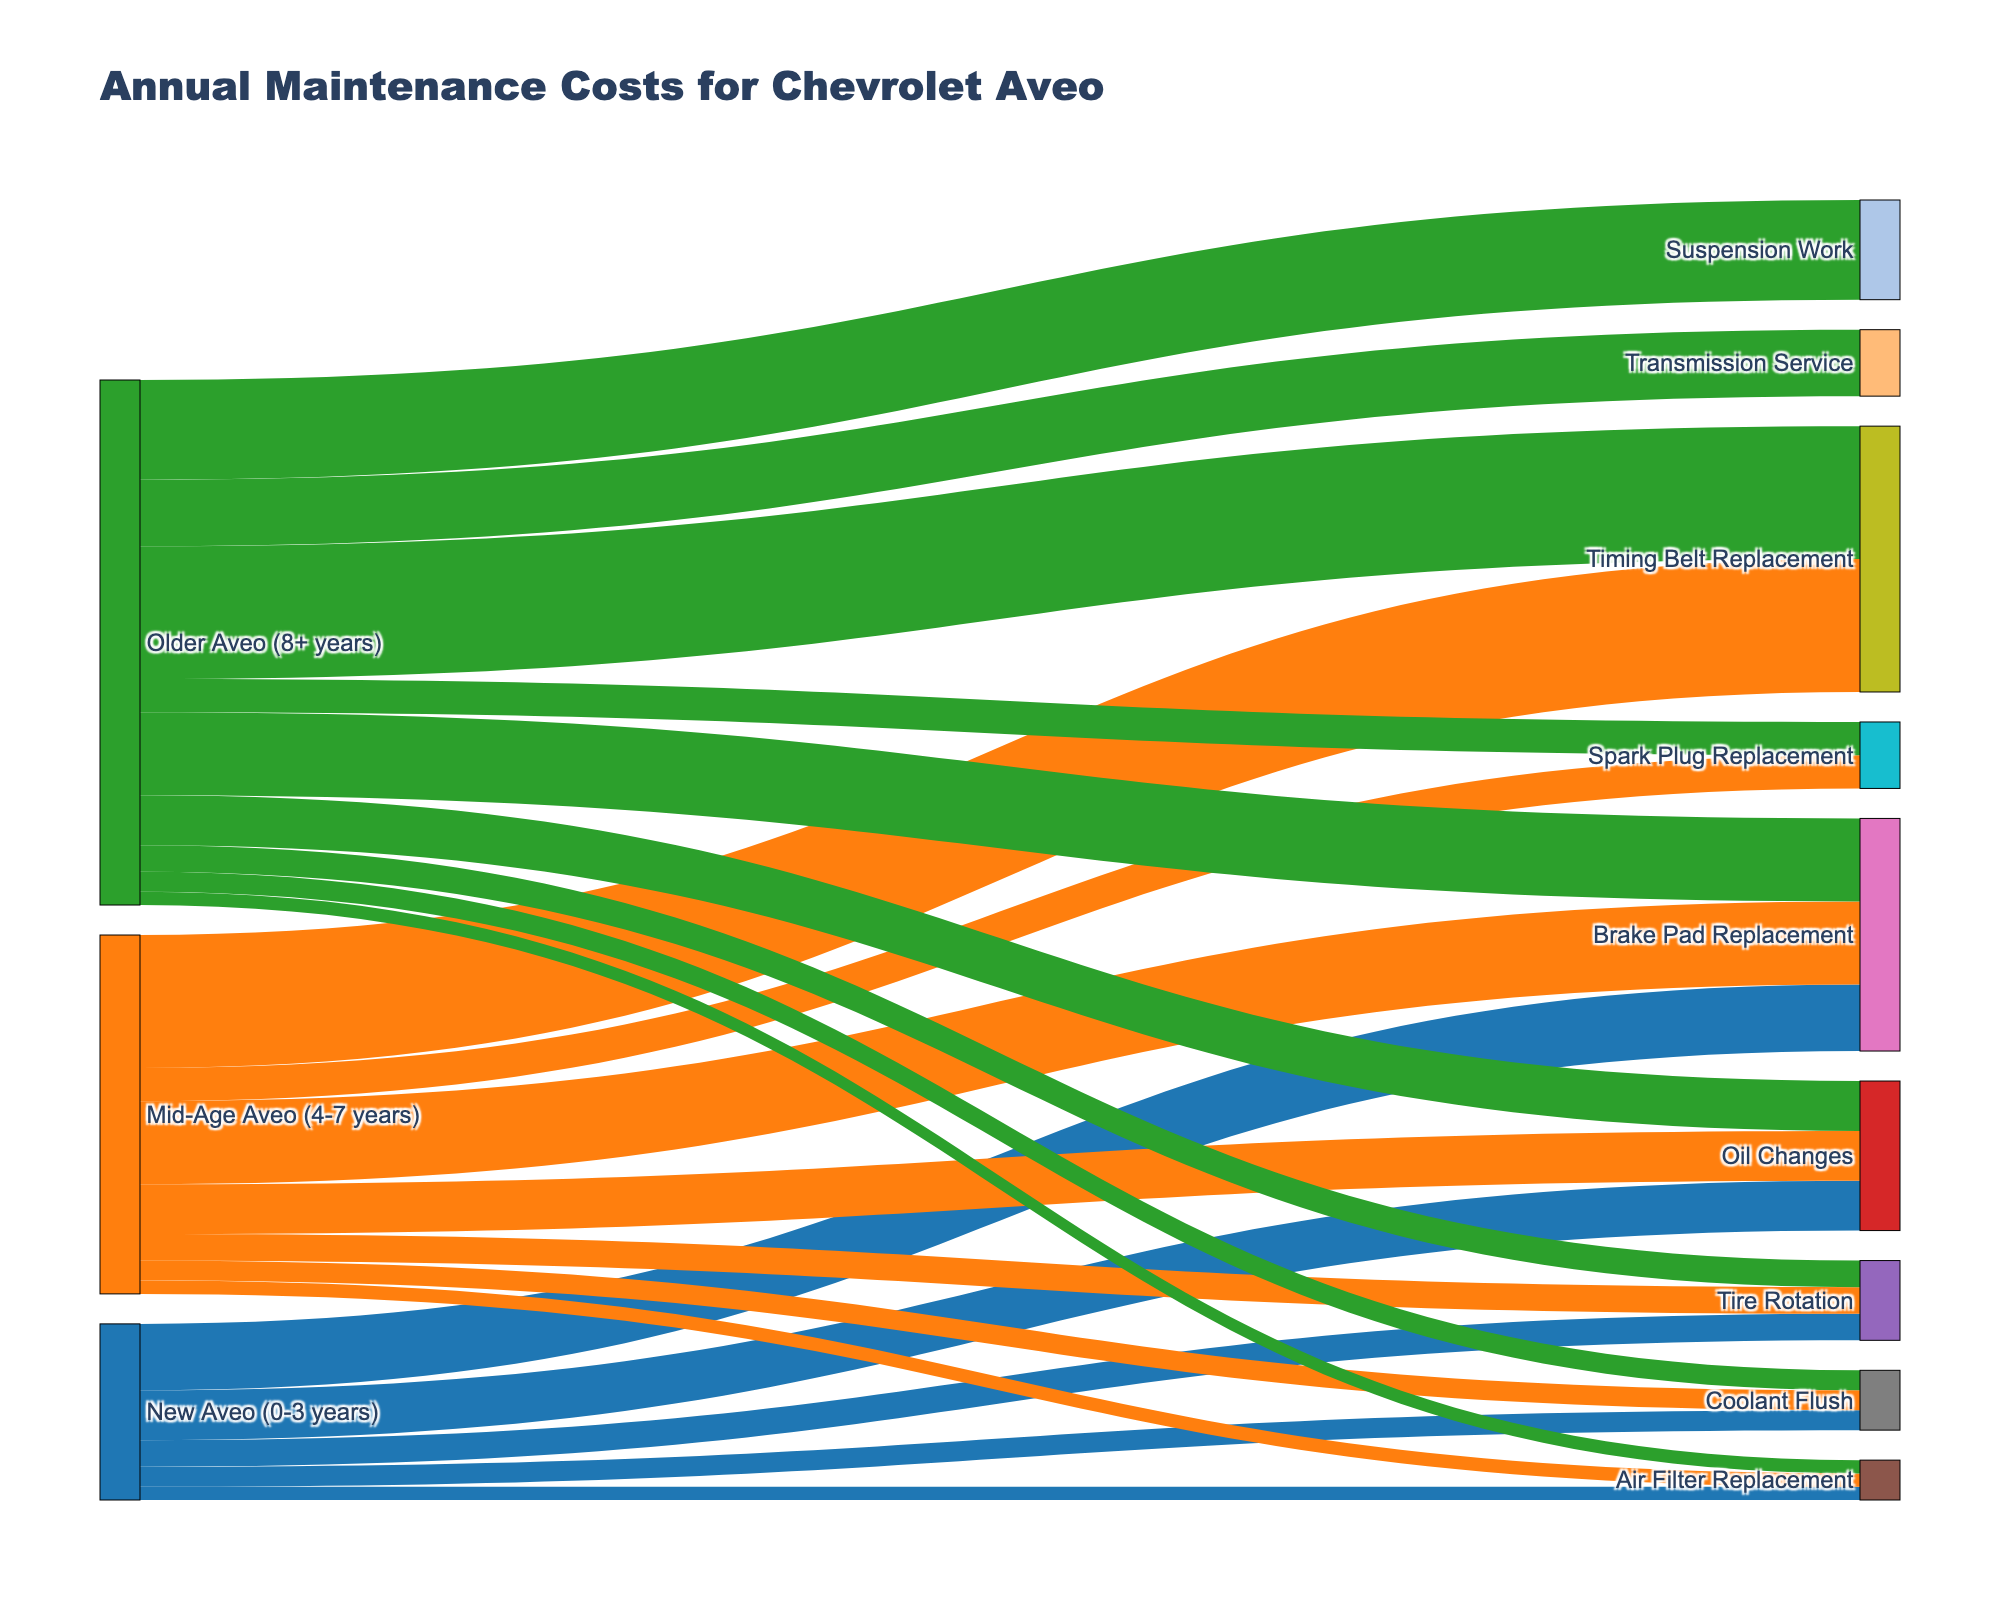Which service type has the highest maintenance cost for a New Aveo (0-3 years)? First, find the columns labeled "New Aveo (0-3 years)" in the diagram. Then, compare the values associated with each service type. The highest value shown is for "Brake Pad Replacement," which is 200.
Answer: Brake Pad Replacement What is the total annual maintenance cost for a Mid-Age Aveo (4-7 years)? Identify all service types connected to "Mid-Age Aveo (4-7 years)" and sum their costs: Oil Changes (150), Tire Rotation (80), Air Filter Replacement (40), Brake Pad Replacement (250), Coolant Flush (60), Timing Belt Replacement (400), Spark Plug Replacement (100). The total is 150 + 80 + 40 + 250 + 60 + 400 + 100 = 1080.
Answer: 1080 How does the cost of Brake Pad Replacement differ between New Aveo (0-3 years) and Older Aveo (8+ years)? Compare the values for "Brake Pad Replacement" connected to "New Aveo (0-3 years)" and "Older Aveo (8+ years)." The values are 200 and 250 respectively. The difference is 250 - 200 = 50.
Answer: 50 Which service type only appears for vehicles older than 8 years? Look for service types connected solely to "Older Aveo (8+ years)" and not to any other vehicle age groups. The service types are "Suspension Work" and "Transmission Service."
Answer: Suspension Work, Transmission Service What is the average cost of servicing an Older Aveo (8+ years)? Identify all service types connected to "Older Aveo (8+ years)" and calculate their average cost. The costs are Oil Changes (150), Tire Rotation (80), Air Filter Replacement (40), Brake Pad Replacement (250), Coolant Flush (60), Timing Belt Replacement (400), Spark Plug Replacement (100), Suspension Work (300), Transmission Service (200). Sum these values: 150 + 80 + 40 + 250 + 60 + 400 + 100 + 300 + 200 = 1580. There are 9 service types, so the average is 1580 / 9 ≈ 175.56.
Answer: 175.56 Which vehicle age group has the highest total cost for Timing Belt Replacement? Compare Timing Belt Replacement costs across the age groups: "Mid-Age Aveo (4-7 years)" and "Older Aveo (8+ years)." Both show a cost of 400. Thus, both groups have the same highest cost.
Answer: Mid-Age Aveo (4-7 years), Older Aveo (8+ years) What is the total cost difference for Oil Changes between all age groups? Calculate the combined cost of Oil Changes across all groups: New Aveo (0-3 years) (150), Mid-Age Aveo (4-7 years) (150), Older Aveo (8+ years) (150). Total is 150 + 150 + 150 = 450. Since all groups have the same cost, the difference is 0.
Answer: 0 Which service type has the lowest maintenance cost regardless of the vehicle age? Identify the service type with the lowest single value among all service types and age groups by examining all the values. The lowest value is 40, for "Air Filter Replacement."
Answer: Air Filter Replacement 